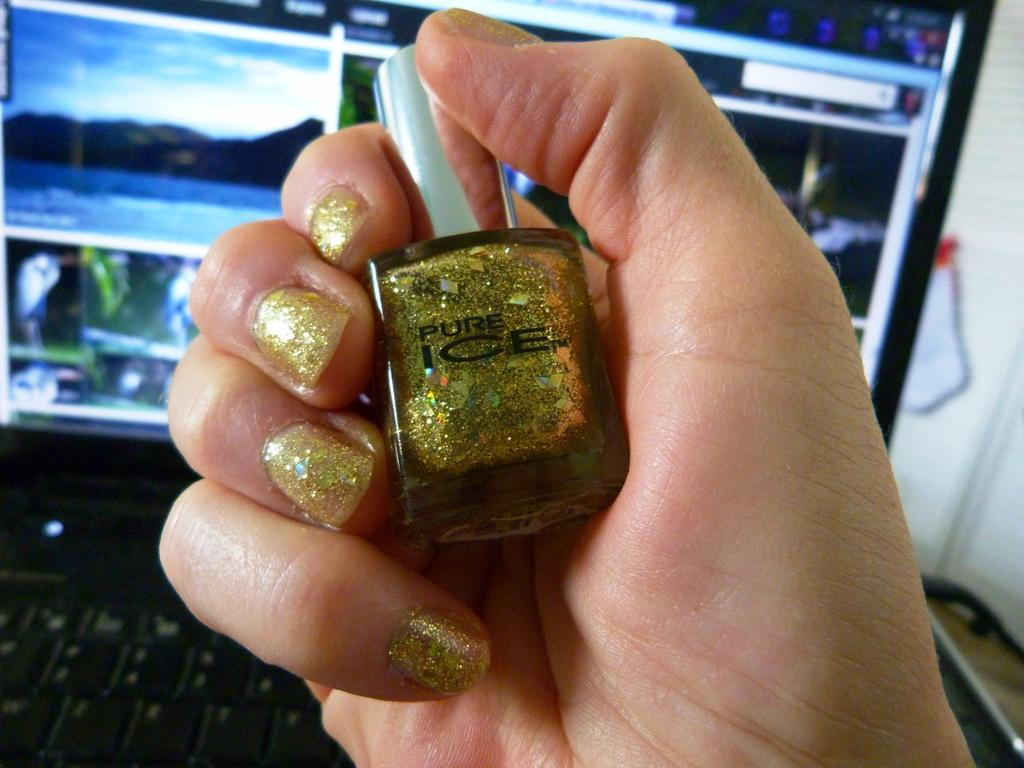<image>
Summarize the visual content of the image. A hand is holding a bottle of gold nail polish labelled Pure Ice. 